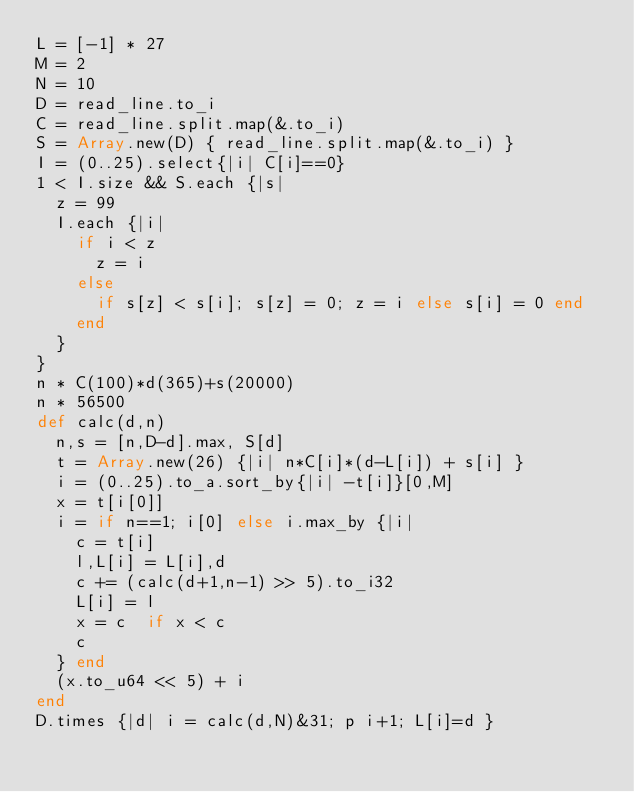<code> <loc_0><loc_0><loc_500><loc_500><_Crystal_>L = [-1] * 27
M = 2
N = 10
D = read_line.to_i
C = read_line.split.map(&.to_i)
S = Array.new(D) { read_line.split.map(&.to_i) }
I = (0..25).select{|i| C[i]==0}
1 < I.size && S.each {|s|
  z = 99
  I.each {|i|
    if i < z
      z = i
    else
      if s[z] < s[i]; s[z] = 0; z = i else s[i] = 0 end
    end
  }
}
n * C(100)*d(365)+s(20000)
n * 56500
def calc(d,n)
  n,s = [n,D-d].max, S[d]
  t = Array.new(26) {|i| n*C[i]*(d-L[i]) + s[i] }
  i = (0..25).to_a.sort_by{|i| -t[i]}[0,M]
  x = t[i[0]]
  i = if n==1; i[0] else i.max_by {|i|
    c = t[i]
    l,L[i] = L[i],d
    c += (calc(d+1,n-1) >> 5).to_i32
    L[i] = l
    x = c  if x < c
    c
  } end
  (x.to_u64 << 5) + i
end
D.times {|d| i = calc(d,N)&31; p i+1; L[i]=d }</code> 